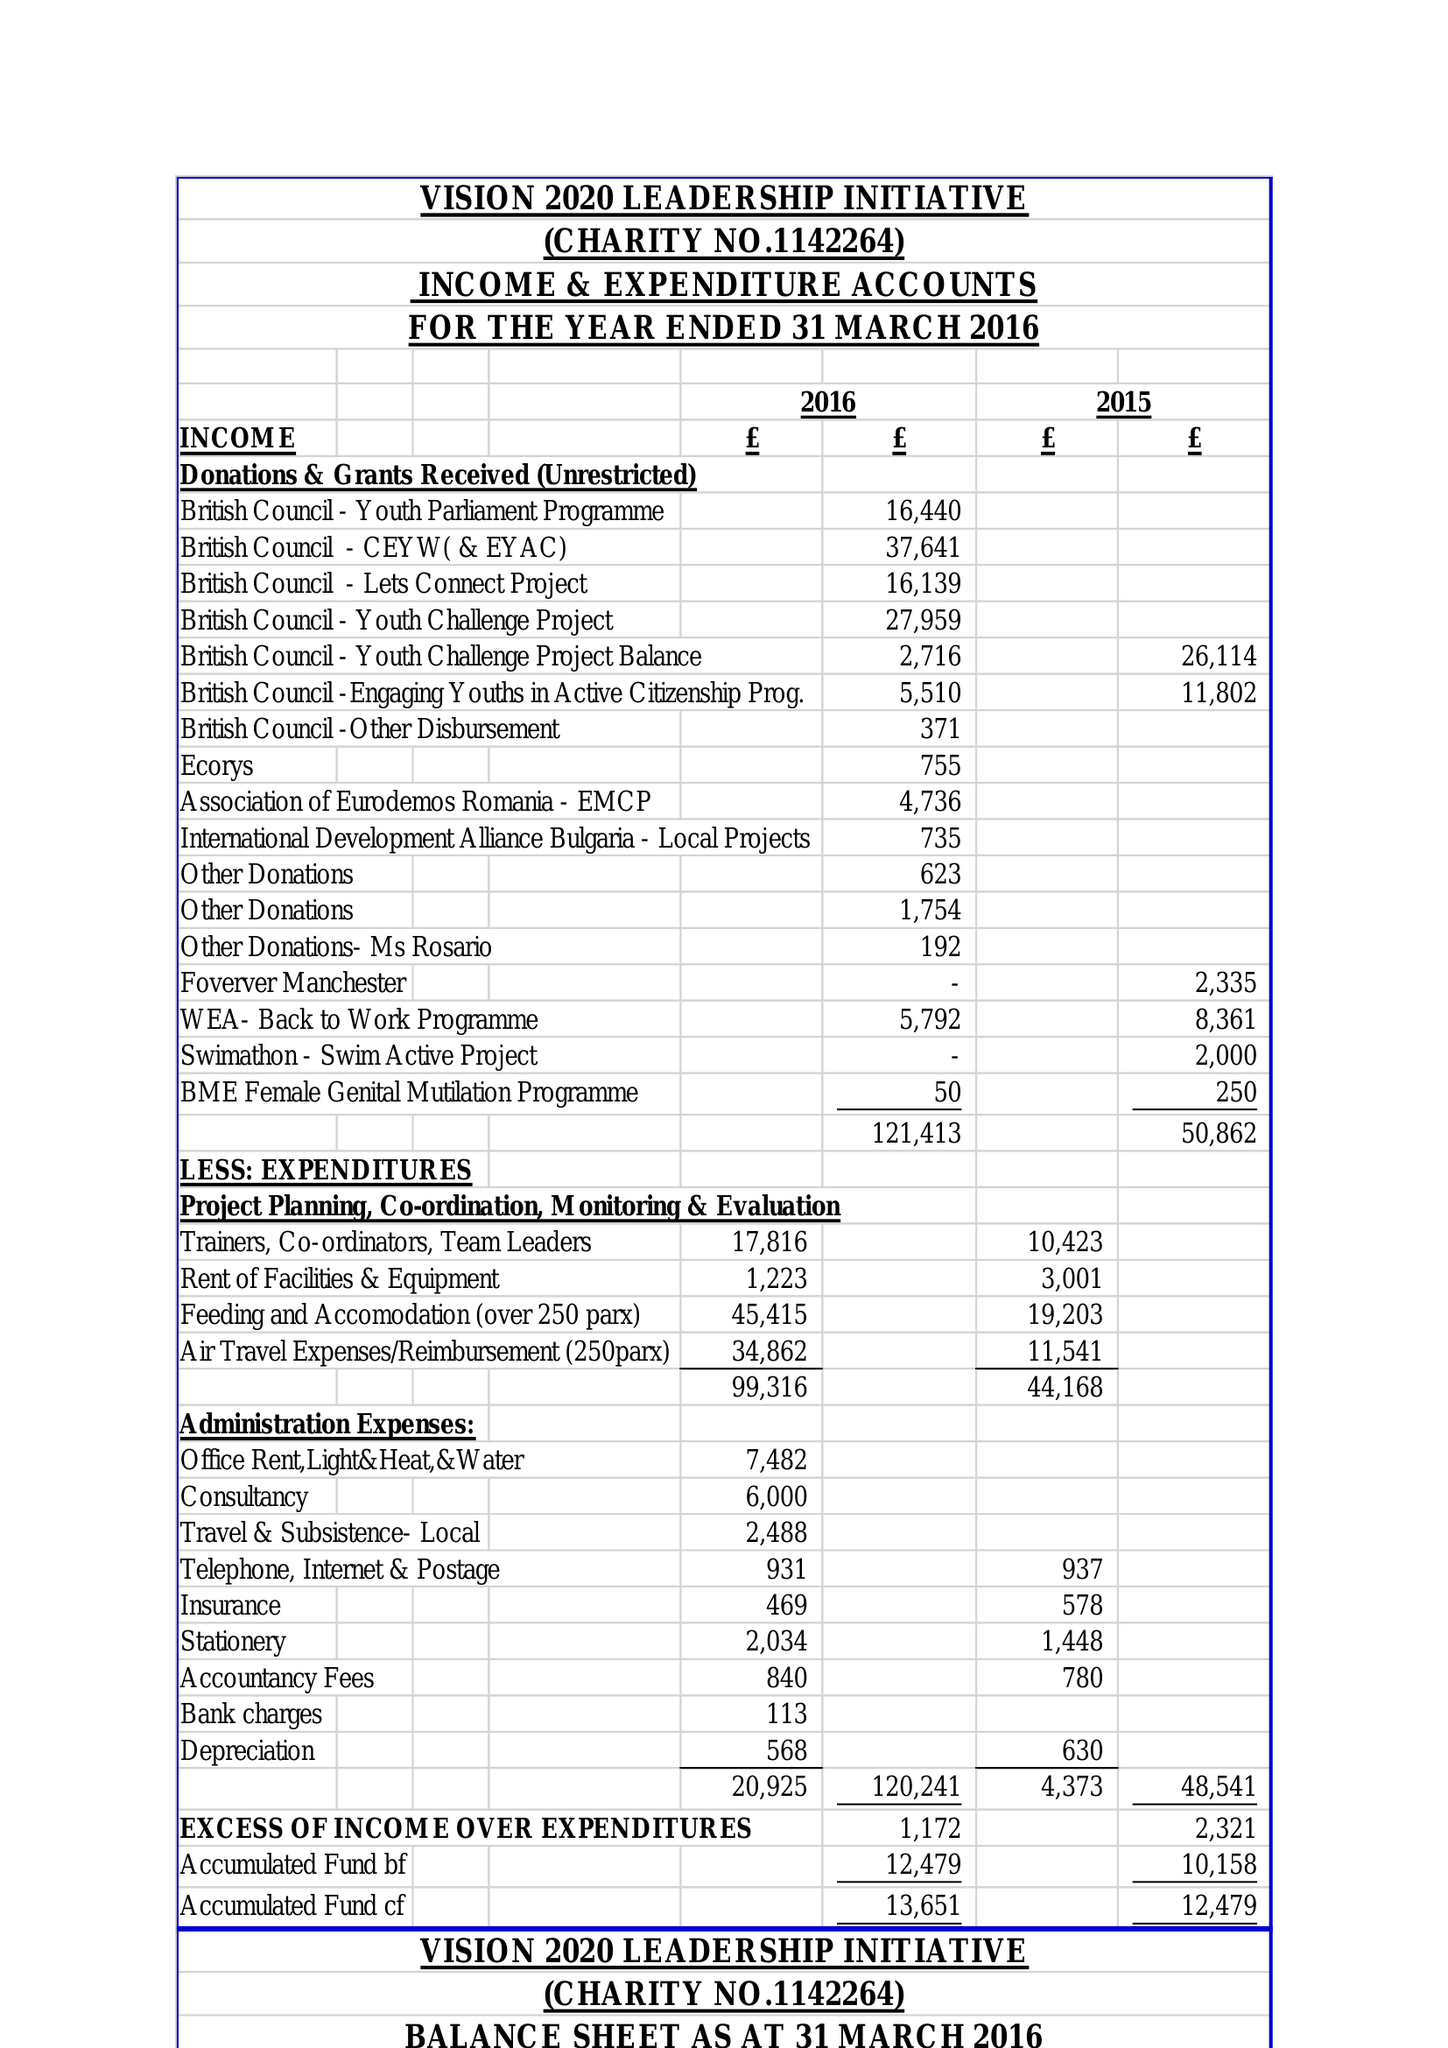What is the value for the charity_number?
Answer the question using a single word or phrase. 1142264 